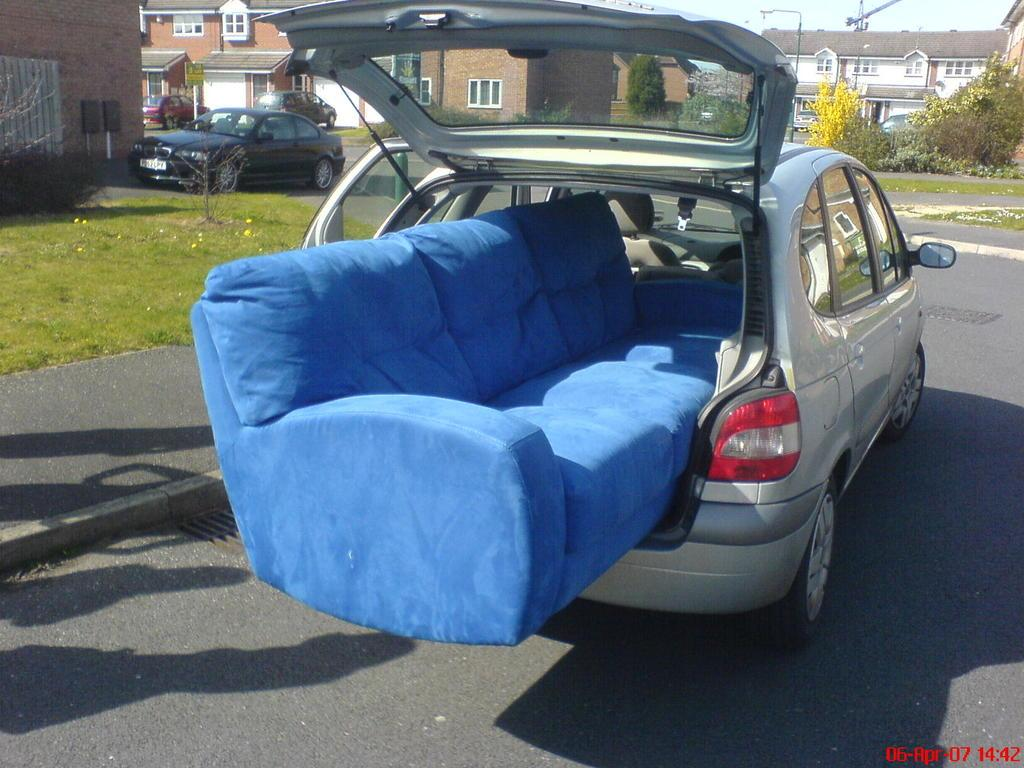What is unusual about the car in the image? There is a couch in the car in the image. What can be seen in the background of the image? There is another car, grass, a plant, a building, a tree, and the sky visible in the background of the image. What type of pain is the boy experiencing while brushing his teeth with the toothpaste in the image? There is no boy or toothpaste present in the image. 